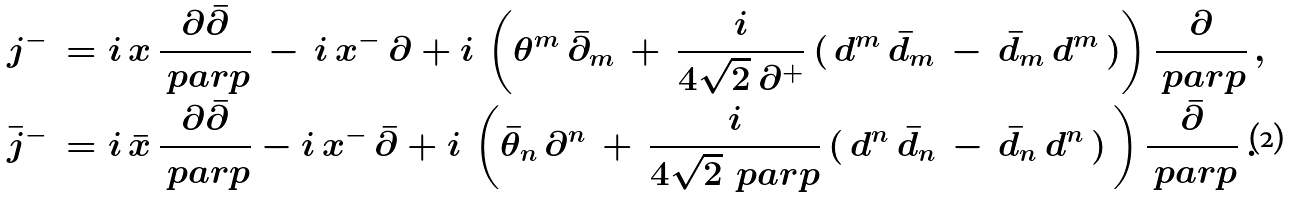<formula> <loc_0><loc_0><loc_500><loc_500>& j ^ { - } \, = i \, x \, \frac { \partial { \bar { \partial } } } { \ p a r p } \, - \, i \, x ^ { - } \, \partial + i \, \left ( \theta ^ { m } \, { \bar { \partial } } _ { m } \, + \, \frac { i } { 4 \sqrt { 2 } \, \partial ^ { + } } \, ( \, d ^ { m } \, { \bar { d } } _ { m } \, - \, { \bar { d } } _ { m } \, d ^ { m } \, ) \right ) \frac { \partial } { \ p a r p } \ , \\ & \bar { j } ^ { - } \, = i \, \bar { x } \, \frac { \partial \bar { \partial } } { \ p a r p } - i \, x ^ { - } \, { \bar { \partial } } + i \, \left ( { \bar { \theta } } _ { n } \, \partial ^ { n } \, + \, \frac { i } { 4 \sqrt { 2 } \, \ p a r p } \, ( \, d ^ { n } \, { \bar { d } } _ { n } \, - \, { \bar { d } } _ { n } \, d ^ { n } \, ) \, \right ) \frac { \bar { \partial } } { \ p a r p } \ .</formula> 